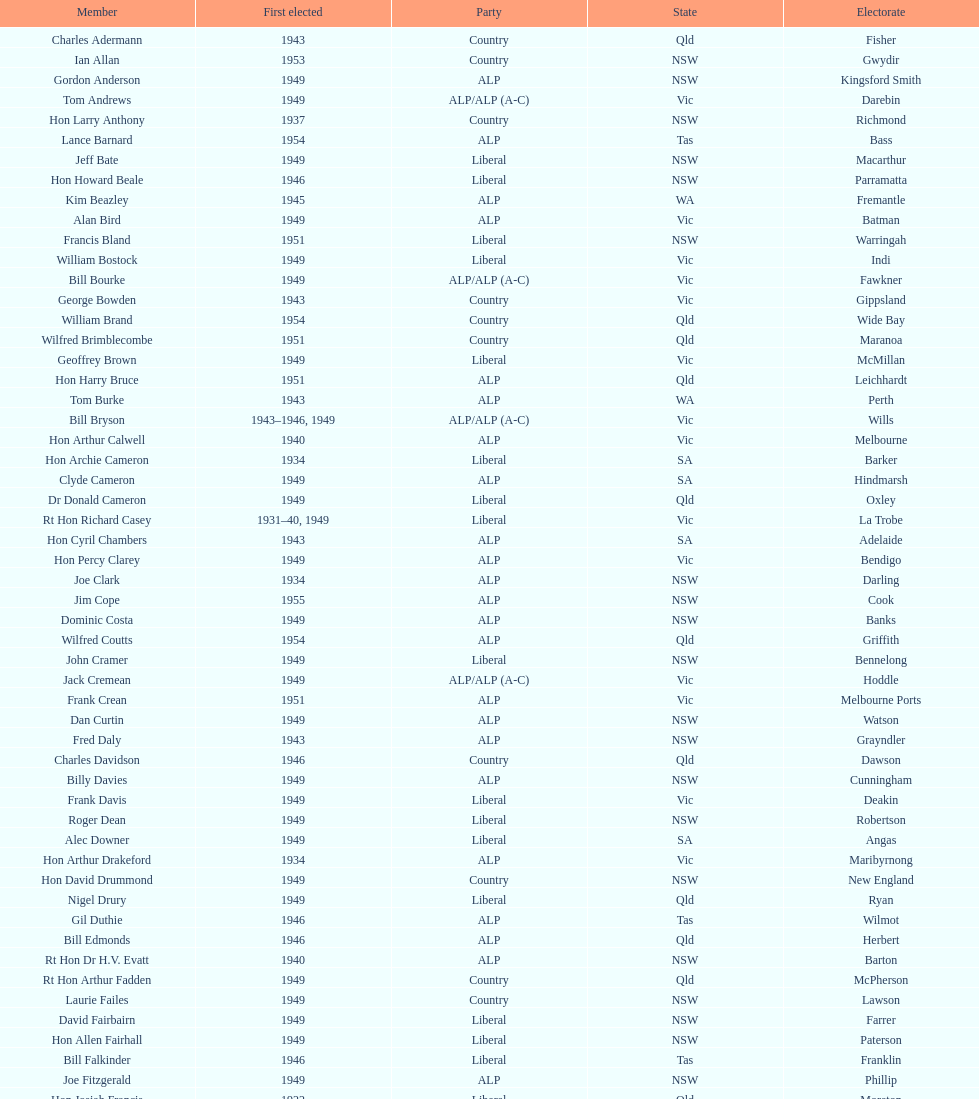Who was the first member to be elected? Charles Adermann. 